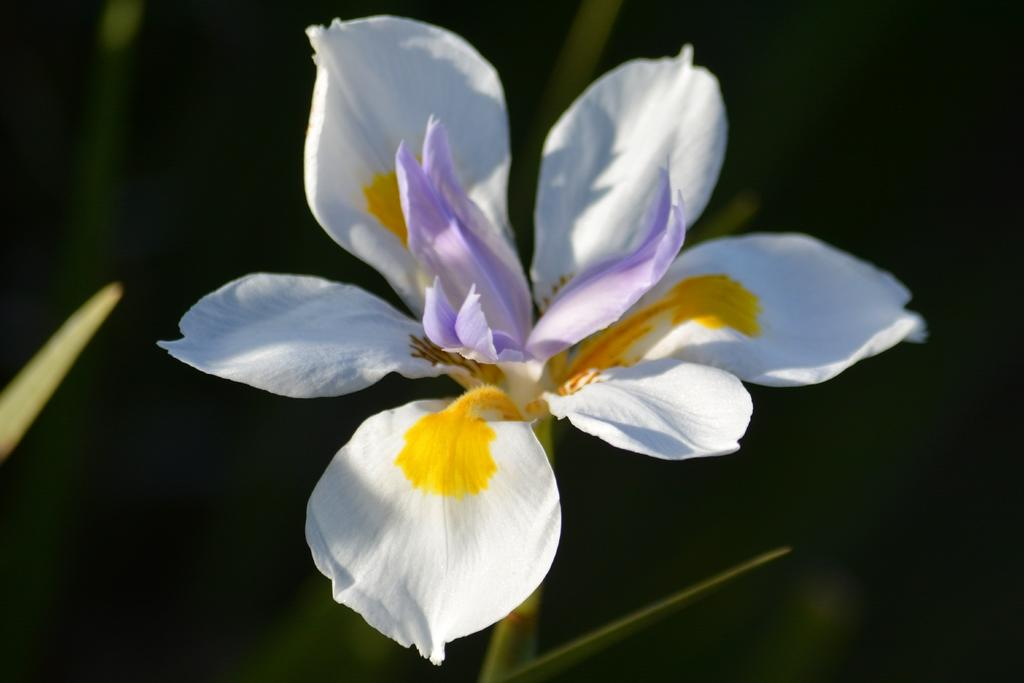What types of flowers can be seen in the image? There is a white flower, a yellow flower, and a purple flower in the image. What is the background color of the image? The background of the image is black. Can you see a snake wearing a crown in the image? No, there is no snake or crown present in the image. The image only features flowers and a black background. 